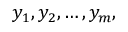<formula> <loc_0><loc_0><loc_500><loc_500>y _ { 1 } , y _ { 2 } , \dots , y _ { m } ,</formula> 